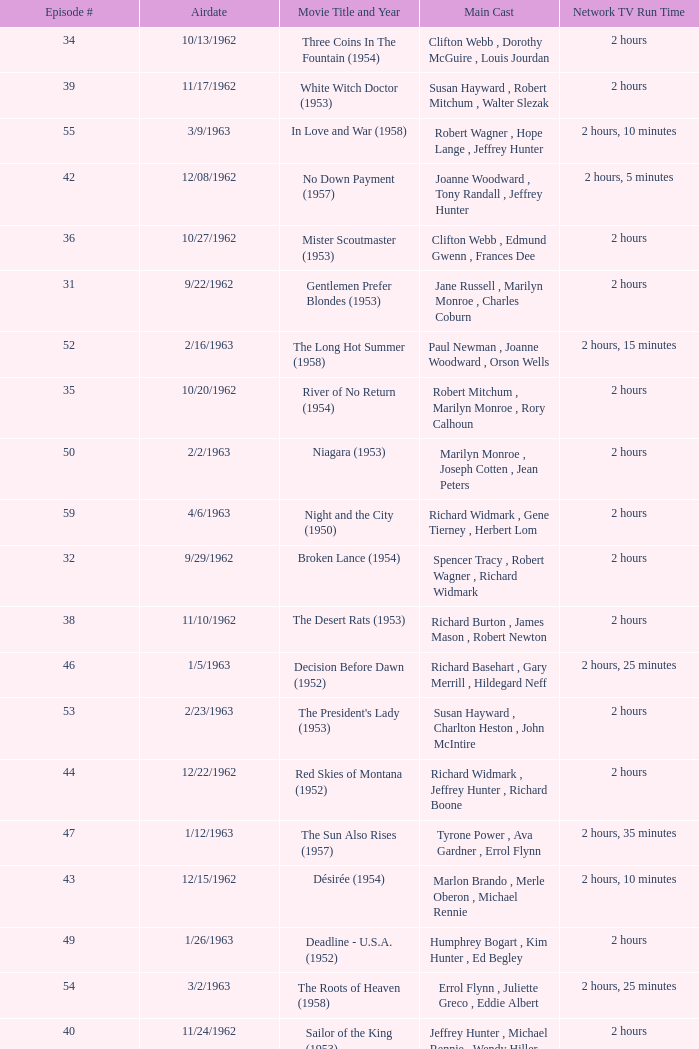Who was the cast on the 3/23/1963 episode? Dana Wynter , Mel Ferrer , Theodore Bikel. 